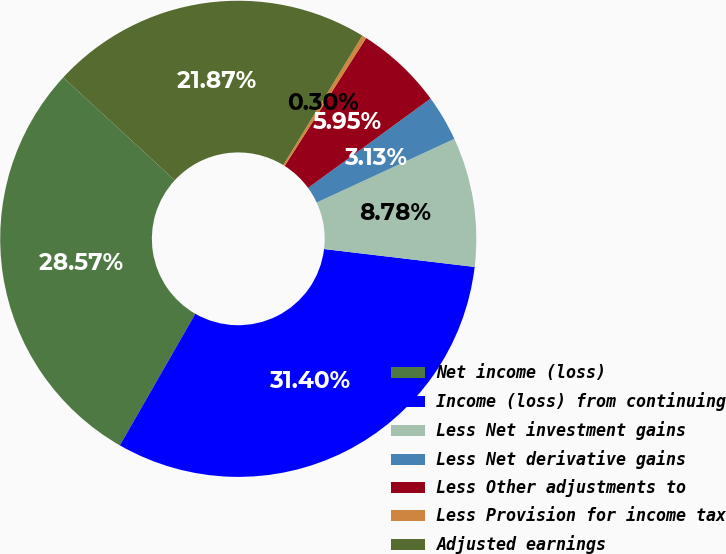<chart> <loc_0><loc_0><loc_500><loc_500><pie_chart><fcel>Net income (loss)<fcel>Income (loss) from continuing<fcel>Less Net investment gains<fcel>Less Net derivative gains<fcel>Less Other adjustments to<fcel>Less Provision for income tax<fcel>Adjusted earnings<nl><fcel>28.57%<fcel>31.4%<fcel>8.78%<fcel>3.13%<fcel>5.95%<fcel>0.3%<fcel>21.87%<nl></chart> 